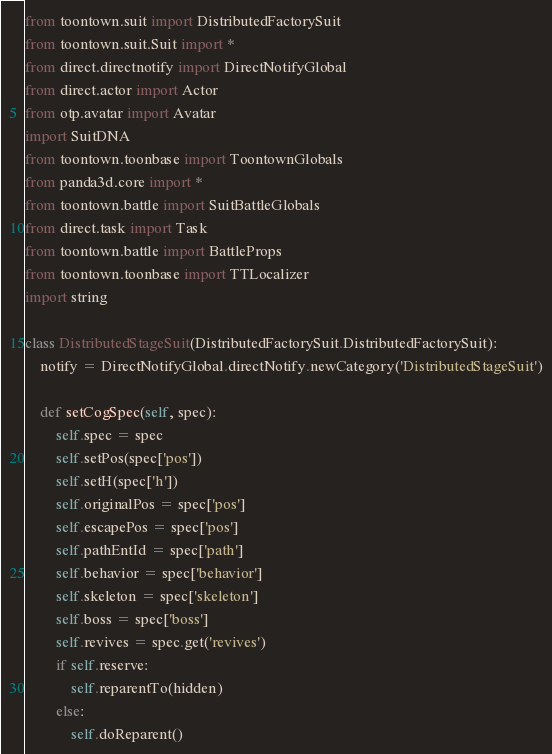<code> <loc_0><loc_0><loc_500><loc_500><_Python_>from toontown.suit import DistributedFactorySuit
from toontown.suit.Suit import *
from direct.directnotify import DirectNotifyGlobal
from direct.actor import Actor
from otp.avatar import Avatar
import SuitDNA
from toontown.toonbase import ToontownGlobals
from panda3d.core import *
from toontown.battle import SuitBattleGlobals
from direct.task import Task
from toontown.battle import BattleProps
from toontown.toonbase import TTLocalizer
import string

class DistributedStageSuit(DistributedFactorySuit.DistributedFactorySuit):
    notify = DirectNotifyGlobal.directNotify.newCategory('DistributedStageSuit')

    def setCogSpec(self, spec):
        self.spec = spec
        self.setPos(spec['pos'])
        self.setH(spec['h'])
        self.originalPos = spec['pos']
        self.escapePos = spec['pos']
        self.pathEntId = spec['path']
        self.behavior = spec['behavior']
        self.skeleton = spec['skeleton']
        self.boss = spec['boss']
        self.revives = spec.get('revives')
        if self.reserve:
            self.reparentTo(hidden)
        else:
            self.doReparent()
</code> 